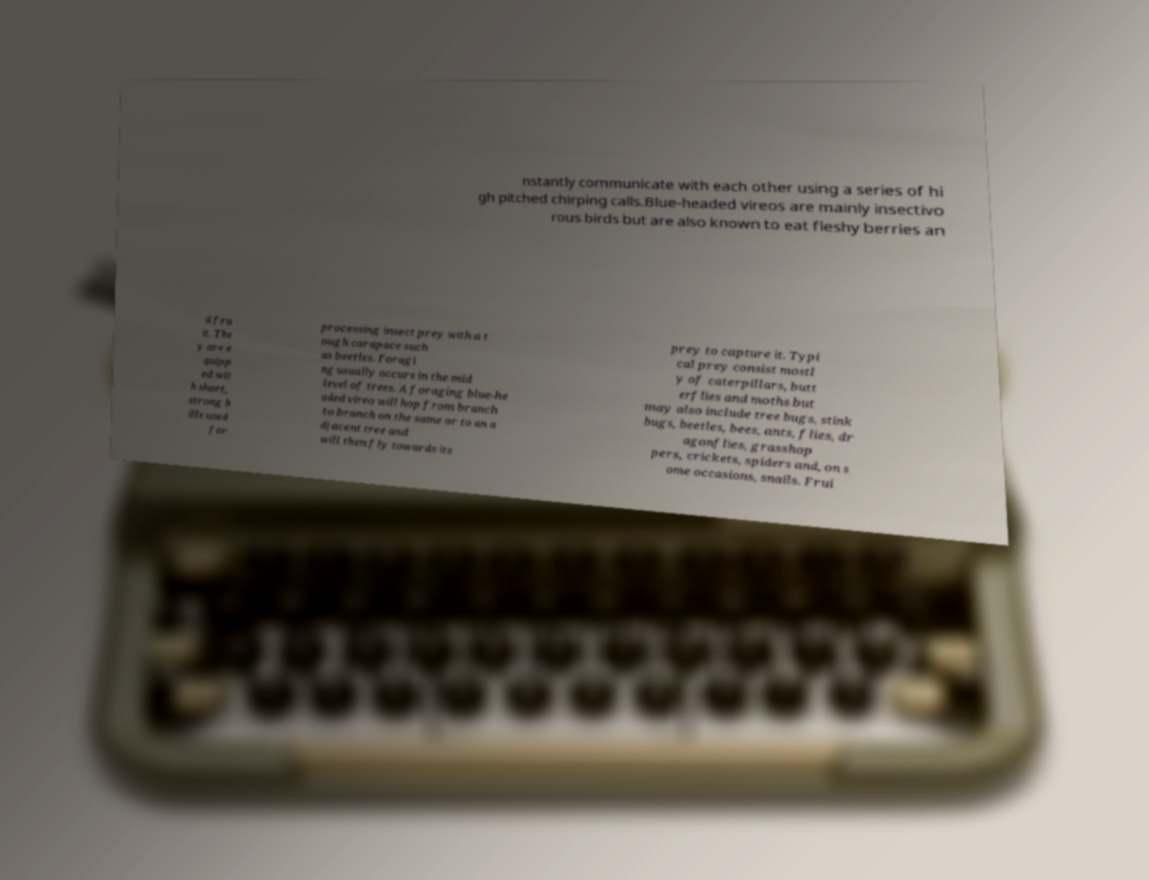Could you assist in decoding the text presented in this image and type it out clearly? nstantly communicate with each other using a series of hi gh pitched chirping calls.Blue-headed vireos are mainly insectivo rous birds but are also known to eat fleshy berries an d fru it. The y are e quipp ed wit h short, strong b ills used for processing insect prey with a t ough carapace such as beetles. Foragi ng usually occurs in the mid level of trees. A foraging blue-he aded vireo will hop from branch to branch on the same or to an a djacent tree and will then fly towards its prey to capture it. Typi cal prey consist mostl y of caterpillars, butt erflies and moths but may also include tree bugs, stink bugs, beetles, bees, ants, flies, dr agonflies, grasshop pers, crickets, spiders and, on s ome occasions, snails. Frui 